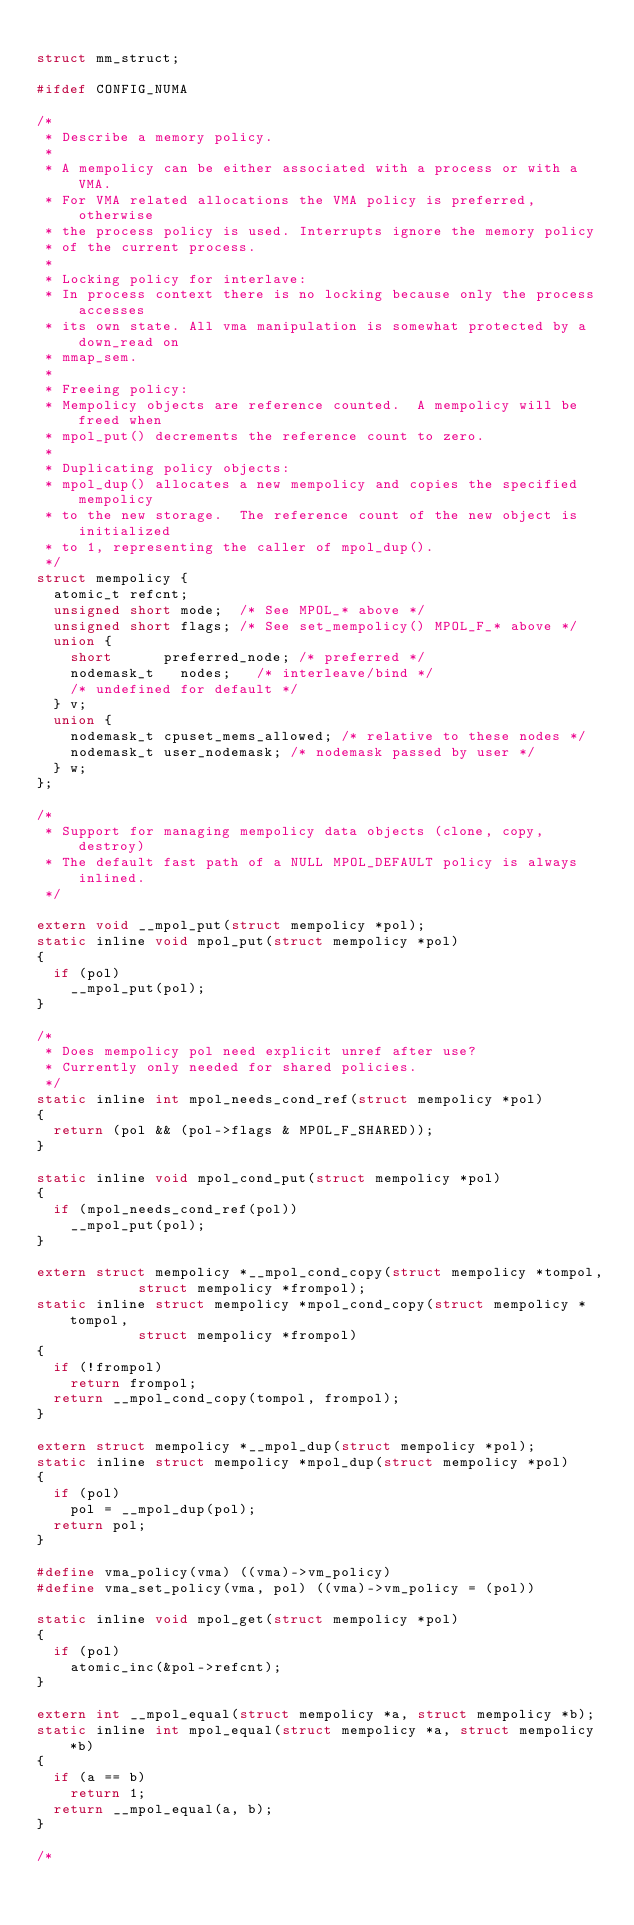Convert code to text. <code><loc_0><loc_0><loc_500><loc_500><_C_>
struct mm_struct;

#ifdef CONFIG_NUMA

/*
 * Describe a memory policy.
 *
 * A mempolicy can be either associated with a process or with a VMA.
 * For VMA related allocations the VMA policy is preferred, otherwise
 * the process policy is used. Interrupts ignore the memory policy
 * of the current process.
 *
 * Locking policy for interlave:
 * In process context there is no locking because only the process accesses
 * its own state. All vma manipulation is somewhat protected by a down_read on
 * mmap_sem.
 *
 * Freeing policy:
 * Mempolicy objects are reference counted.  A mempolicy will be freed when
 * mpol_put() decrements the reference count to zero.
 *
 * Duplicating policy objects:
 * mpol_dup() allocates a new mempolicy and copies the specified mempolicy
 * to the new storage.  The reference count of the new object is initialized
 * to 1, representing the caller of mpol_dup().
 */
struct mempolicy {
	atomic_t refcnt;
	unsigned short mode; 	/* See MPOL_* above */
	unsigned short flags;	/* See set_mempolicy() MPOL_F_* above */
	union {
		short 		 preferred_node; /* preferred */
		nodemask_t	 nodes;		/* interleave/bind */
		/* undefined for default */
	} v;
	union {
		nodemask_t cpuset_mems_allowed;	/* relative to these nodes */
		nodemask_t user_nodemask;	/* nodemask passed by user */
	} w;
};

/*
 * Support for managing mempolicy data objects (clone, copy, destroy)
 * The default fast path of a NULL MPOL_DEFAULT policy is always inlined.
 */

extern void __mpol_put(struct mempolicy *pol);
static inline void mpol_put(struct mempolicy *pol)
{
	if (pol)
		__mpol_put(pol);
}

/*
 * Does mempolicy pol need explicit unref after use?
 * Currently only needed for shared policies.
 */
static inline int mpol_needs_cond_ref(struct mempolicy *pol)
{
	return (pol && (pol->flags & MPOL_F_SHARED));
}

static inline void mpol_cond_put(struct mempolicy *pol)
{
	if (mpol_needs_cond_ref(pol))
		__mpol_put(pol);
}

extern struct mempolicy *__mpol_cond_copy(struct mempolicy *tompol,
					  struct mempolicy *frompol);
static inline struct mempolicy *mpol_cond_copy(struct mempolicy *tompol,
						struct mempolicy *frompol)
{
	if (!frompol)
		return frompol;
	return __mpol_cond_copy(tompol, frompol);
}

extern struct mempolicy *__mpol_dup(struct mempolicy *pol);
static inline struct mempolicy *mpol_dup(struct mempolicy *pol)
{
	if (pol)
		pol = __mpol_dup(pol);
	return pol;
}

#define vma_policy(vma) ((vma)->vm_policy)
#define vma_set_policy(vma, pol) ((vma)->vm_policy = (pol))

static inline void mpol_get(struct mempolicy *pol)
{
	if (pol)
		atomic_inc(&pol->refcnt);
}

extern int __mpol_equal(struct mempolicy *a, struct mempolicy *b);
static inline int mpol_equal(struct mempolicy *a, struct mempolicy *b)
{
	if (a == b)
		return 1;
	return __mpol_equal(a, b);
}

/*</code> 